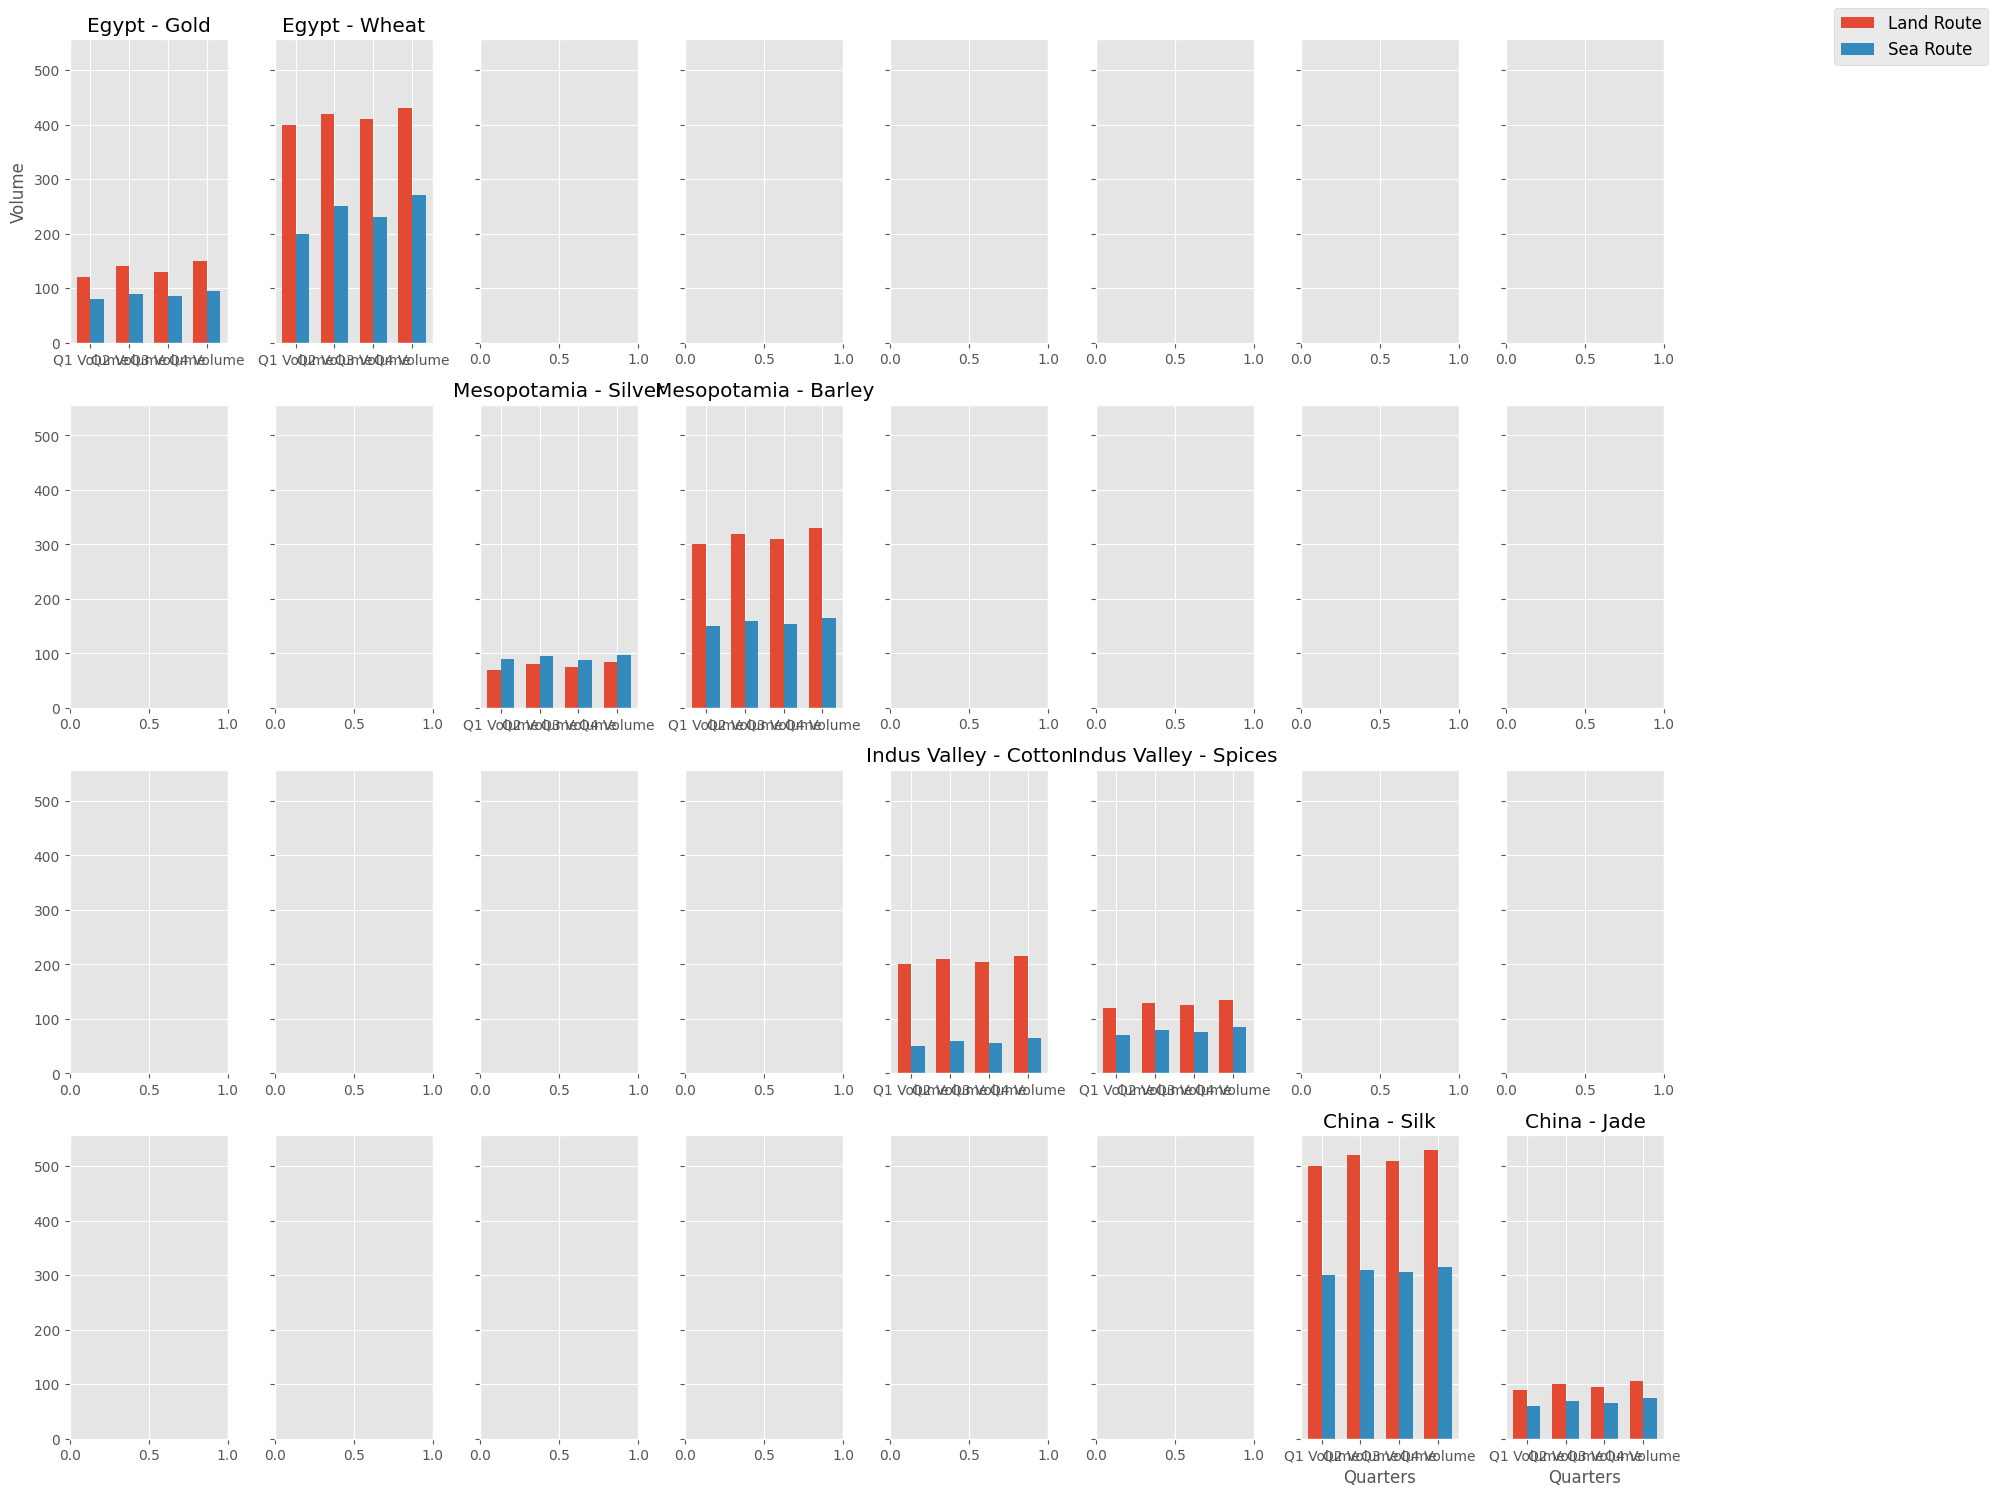Which civilization had the highest volume of land route trade for all commodities in Q2? To find the highest volume of land route trade, look at the data for Q2 across all commodities for each civilization using the land route. Summing the Q2 volumes for Egypt, Mesopotamia, Indus Valley, and China gives us: 
- Egypt: Gold (140) + Wheat (420) = 560 
- Mesopotamia: Silver (80) + Barley (320) = 400 
- Indus Valley: Cotton (210) + Spices (130) = 340 
- China: Silk (520) + Jade (100) = 620 
Therefore, China has the highest volume with 620.
Answer: China What was the total trade volume of Wheat for Egypt in Q4 combining both land and sea routes? Summing the Q4 volumes by both land and sea routes for Wheat in Egypt: Wheat (Land Route) = 430 and Wheat (Sea Route) = 270. The total volume = 430 + 270 = 700.
Answer: 700 In Q3, which civilization traded more on sea routes, Egypt with Wheat or Indus Valley with Spices? Comparing the Q3 volumes for sea routes: Egypt Wheat Sea Route (230) vs. Indus Valley Spices Sea Route (75). Egypt traded more with Wheat (230).
Answer: Egypt with Wheat How does the Q1 land trade volume for China Silk compare to Egypt Wheat? China Silk Q1 land volume is 500 and Egypt Wheat Q1 land volume is 400. Comparing them shows that China traded 100 units more than Egypt.
Answer: China Silk is higher by 100 What was the average quarterly trade volume for Jade via sea route for China in 2023? Calculate the average volume by summing the quarterly volumes and dividing by 4: (60 + 70 + 65 + 75) / 4 = 270 / 4 = 67.5.
Answer: 67.5 Which commodity had the largest difference in trade volume between land and sea routes in Q2 across all civilizations? Evaluating each commodity's land and sea route differences:
- Gold: Egypt Land (140) - Sea (90) = 50
- Wheat: Egypt Land (420) - Sea (250) = 170
- Silver: Mesopotamia Land (80) - Sea (95) = 15
- Barley: Mesopotamia Land (320) - Sea (160) = 160
- Cotton: Indus Valley Land (210) - Sea (60) = 150
- Spices: Indus Valley Land (130) - Sea (80) = 50
- Silk: China Land (520) - Sea (310) = 210
- Jade: China Land (100) - Sea (70) = 30
Silk has the largest difference of 210 units.
Answer: Silk What was the overall trend for the trade volume of Barley in Mesopotamia throughout the four quarters? Examine the quarterly volumes for Barley via land and sea routes in Mesopotamia: Land Route (300, 320, 310, 330) and Sea Route (150, 160, 155, 165). Both routes show a general increasing trend across quarters.
Answer: Increasing trend Which civilization traded the least amount of any commodity via any trade route in Q1? Look for the smallest Q1 volume across all civilizations and commodities: The lowest figures are Silver (70 for Mesopotamia Land), Spices (70 for Indus Valley Sea), Jade (60 for China Sea). The minimum is for Jade (60).
Answer: China with Jade via Sea Between Egypt's Gold and Mesopotamia's Silver, which civilization had more stable trade volumes in Q3 via sea route? Stability can be measured by the consistency in volumes. Egypt Gold Sea Route (85) and Mesopotamia Silver Sea Route (88). Since Mesopotamia has a volume slightly higher, it appears slightly more stable across the different commodities, although both are quite close.
Answer: Both quite stable 